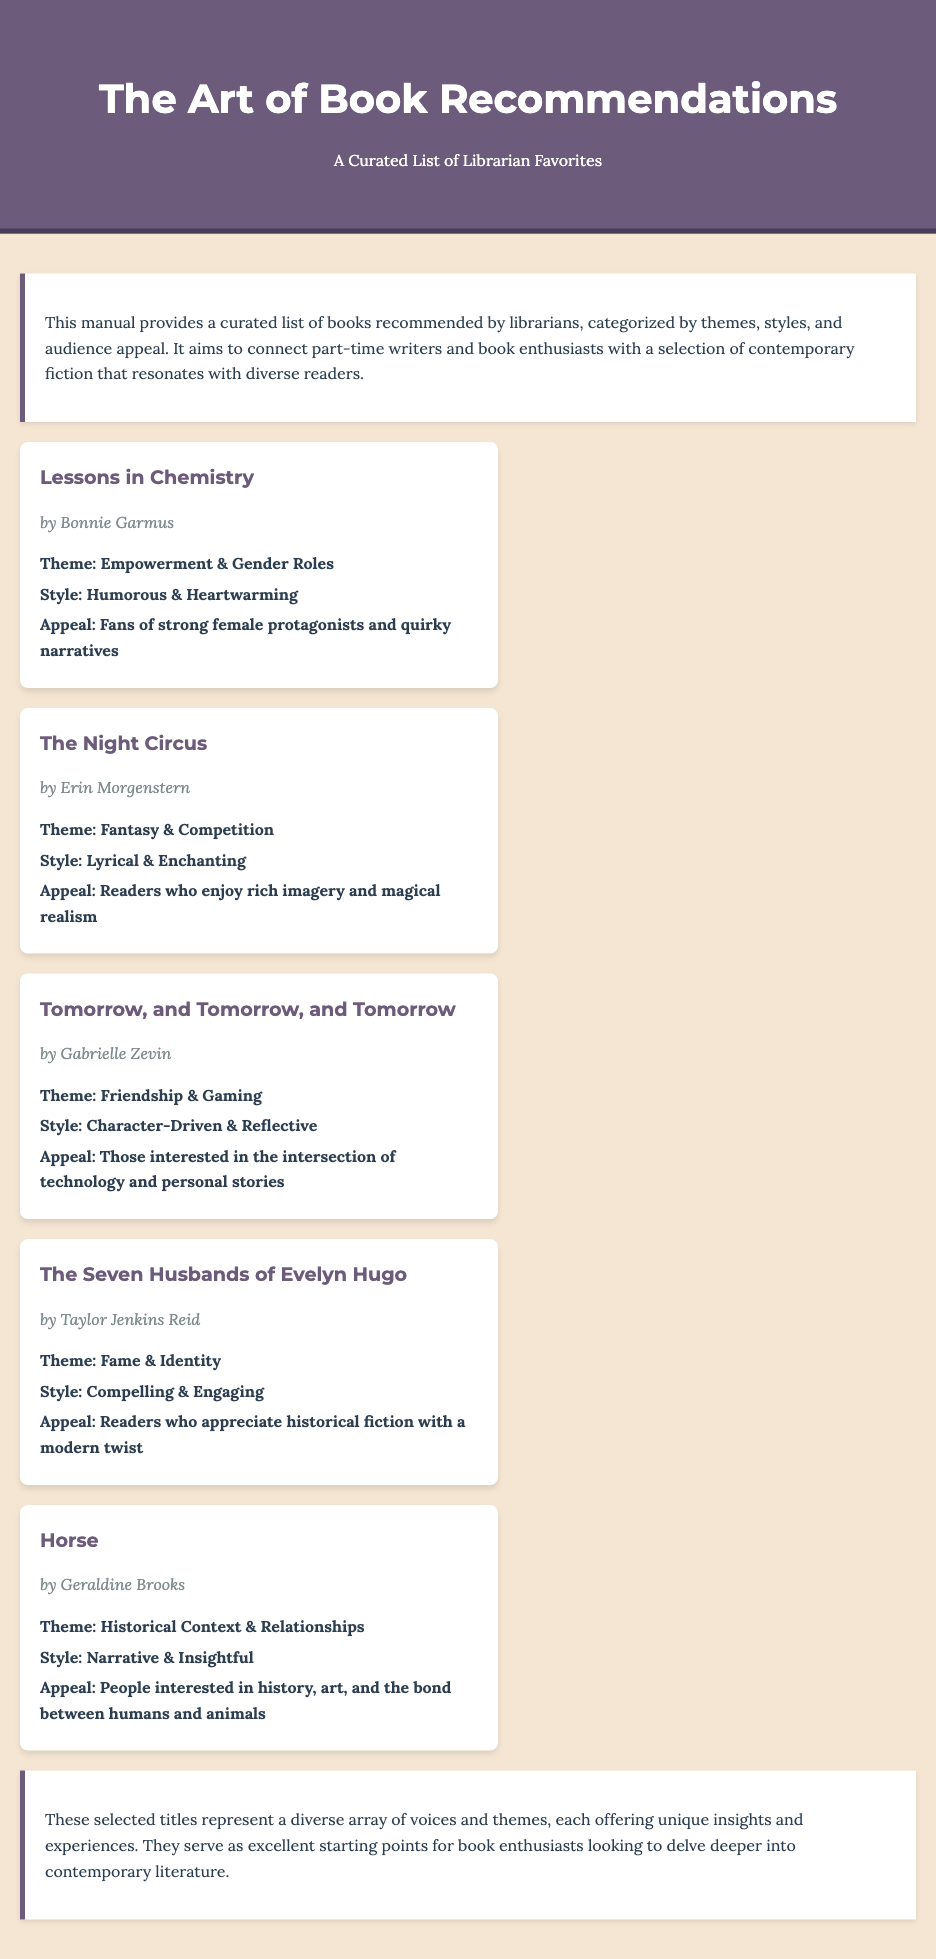What is the title of the first book listed? The first book in the list is identified by its title, which is "Lessons in Chemistry."
Answer: Lessons in Chemistry Who is the author of "The Night Circus"? The author of "The Night Circus" is provided in the document as Erin Morgenstern.
Answer: Erin Morgenstern What theme is associated with "Tomorrow, and Tomorrow, and Tomorrow"? The theme for this book is mentioned in the book description as "Friendship & Gaming."
Answer: Friendship & Gaming What style is described for "The Seven Husbands of Evelyn Hugo"? The document specifies that the style for this book is "Compelling & Engaging."
Answer: Compelling & Engaging How many books are listed in total? The total number of books can be counted from the book cards presented in the document, which amounts to five books.
Answer: 5 What audience appeal is noted for "Horse"? The document mentions that the appeal for "Horse" includes "People interested in history, art, and the bond between humans and animals."
Answer: People interested in history, art, and the bond between humans and animals What is the main purpose of this manual? The manual's purpose is outlined in the introduction as providing a curated list of recommended books by librarians.
Answer: Providing a curated list of recommended books by librarians What color is used for the header background? The document indicates that the header background color is "#6c5b7b," which corresponds to a specific shade of purple.
Answer: #6c5b7b What type of narratives does "Lessons in Chemistry" appeal to? The document states that "Lessons in Chemistry" appeals to "Fans of strong female protagonists and quirky narratives."
Answer: Fans of strong female protagonists and quirky narratives 